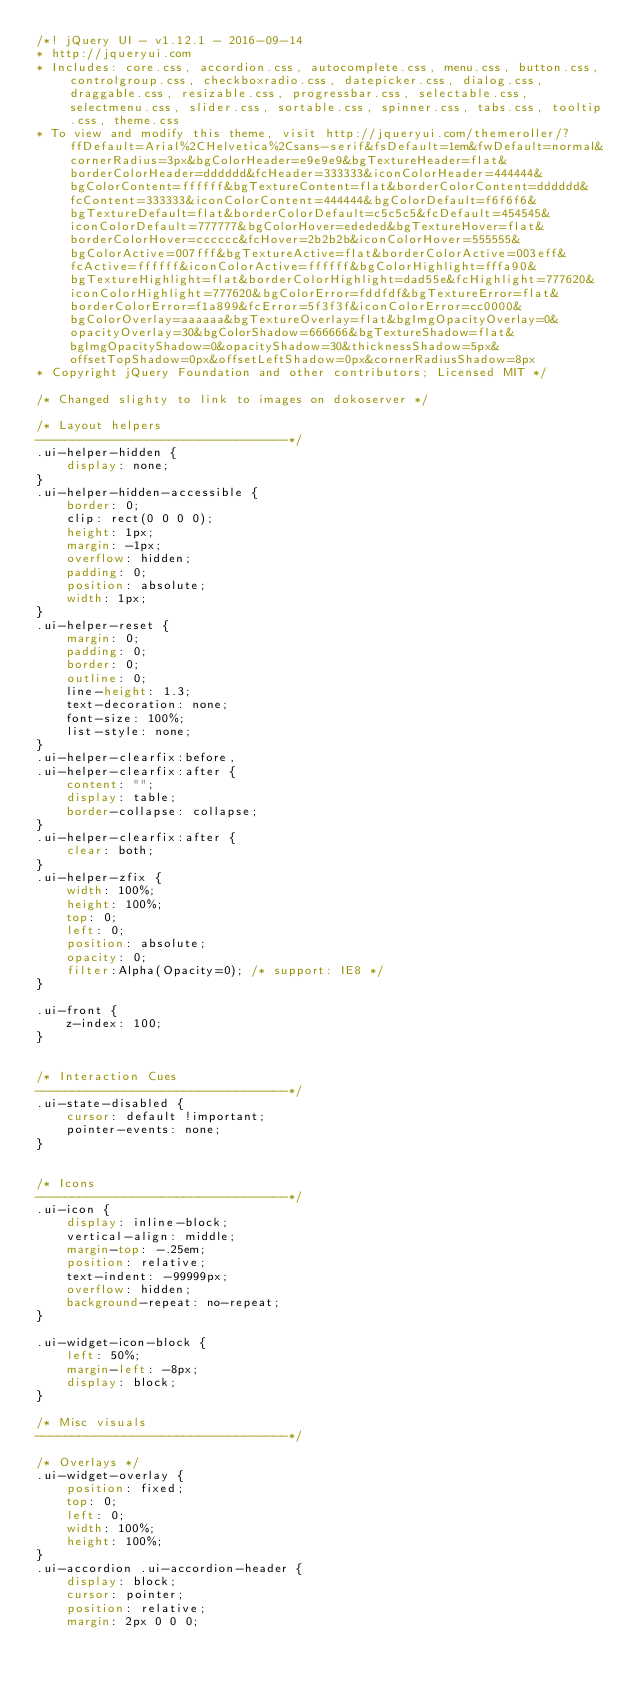<code> <loc_0><loc_0><loc_500><loc_500><_CSS_>/*! jQuery UI - v1.12.1 - 2016-09-14
* http://jqueryui.com
* Includes: core.css, accordion.css, autocomplete.css, menu.css, button.css, controlgroup.css, checkboxradio.css, datepicker.css, dialog.css, draggable.css, resizable.css, progressbar.css, selectable.css, selectmenu.css, slider.css, sortable.css, spinner.css, tabs.css, tooltip.css, theme.css
* To view and modify this theme, visit http://jqueryui.com/themeroller/?ffDefault=Arial%2CHelvetica%2Csans-serif&fsDefault=1em&fwDefault=normal&cornerRadius=3px&bgColorHeader=e9e9e9&bgTextureHeader=flat&borderColorHeader=dddddd&fcHeader=333333&iconColorHeader=444444&bgColorContent=ffffff&bgTextureContent=flat&borderColorContent=dddddd&fcContent=333333&iconColorContent=444444&bgColorDefault=f6f6f6&bgTextureDefault=flat&borderColorDefault=c5c5c5&fcDefault=454545&iconColorDefault=777777&bgColorHover=ededed&bgTextureHover=flat&borderColorHover=cccccc&fcHover=2b2b2b&iconColorHover=555555&bgColorActive=007fff&bgTextureActive=flat&borderColorActive=003eff&fcActive=ffffff&iconColorActive=ffffff&bgColorHighlight=fffa90&bgTextureHighlight=flat&borderColorHighlight=dad55e&fcHighlight=777620&iconColorHighlight=777620&bgColorError=fddfdf&bgTextureError=flat&borderColorError=f1a899&fcError=5f3f3f&iconColorError=cc0000&bgColorOverlay=aaaaaa&bgTextureOverlay=flat&bgImgOpacityOverlay=0&opacityOverlay=30&bgColorShadow=666666&bgTextureShadow=flat&bgImgOpacityShadow=0&opacityShadow=30&thicknessShadow=5px&offsetTopShadow=0px&offsetLeftShadow=0px&cornerRadiusShadow=8px
* Copyright jQuery Foundation and other contributors; Licensed MIT */

/* Changed slighty to link to images on dokoserver */

/* Layout helpers
----------------------------------*/
.ui-helper-hidden {
	display: none;
}
.ui-helper-hidden-accessible {
	border: 0;
	clip: rect(0 0 0 0);
	height: 1px;
	margin: -1px;
	overflow: hidden;
	padding: 0;
	position: absolute;
	width: 1px;
}
.ui-helper-reset {
	margin: 0;
	padding: 0;
	border: 0;
	outline: 0;
	line-height: 1.3;
	text-decoration: none;
	font-size: 100%;
	list-style: none;
}
.ui-helper-clearfix:before,
.ui-helper-clearfix:after {
	content: "";
	display: table;
	border-collapse: collapse;
}
.ui-helper-clearfix:after {
	clear: both;
}
.ui-helper-zfix {
	width: 100%;
	height: 100%;
	top: 0;
	left: 0;
	position: absolute;
	opacity: 0;
	filter:Alpha(Opacity=0); /* support: IE8 */
}

.ui-front {
	z-index: 100;
}


/* Interaction Cues
----------------------------------*/
.ui-state-disabled {
	cursor: default !important;
	pointer-events: none;
}


/* Icons
----------------------------------*/
.ui-icon {
	display: inline-block;
	vertical-align: middle;
	margin-top: -.25em;
	position: relative;
	text-indent: -99999px;
	overflow: hidden;
	background-repeat: no-repeat;
}

.ui-widget-icon-block {
	left: 50%;
	margin-left: -8px;
	display: block;
}

/* Misc visuals
----------------------------------*/

/* Overlays */
.ui-widget-overlay {
	position: fixed;
	top: 0;
	left: 0;
	width: 100%;
	height: 100%;
}
.ui-accordion .ui-accordion-header {
	display: block;
	cursor: pointer;
	position: relative;
	margin: 2px 0 0 0;</code> 